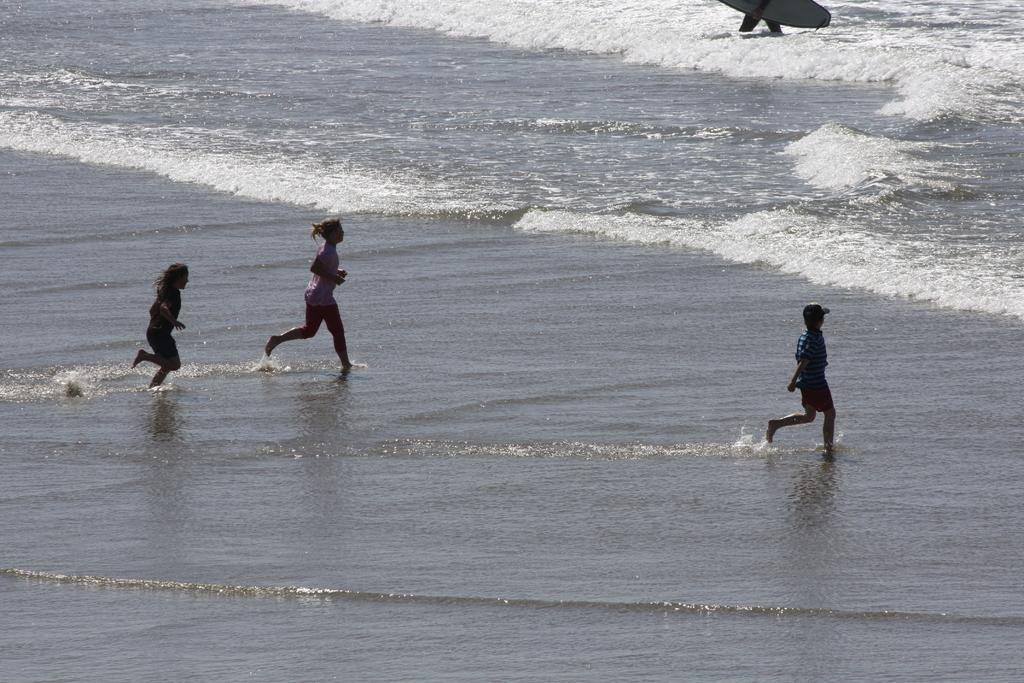What are the three persons in the image doing? The three persons in the image are running in the water. Is there any equipment being used by the persons in the image? Yes, one person is holding a surfboard. What type of mark can be seen on the turkey in the image? There is no turkey present in the image, so no mark can be seen on it. 